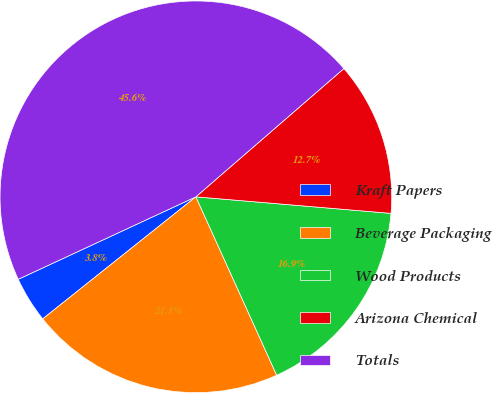Convert chart to OTSL. <chart><loc_0><loc_0><loc_500><loc_500><pie_chart><fcel>Kraft Papers<fcel>Beverage Packaging<fcel>Wood Products<fcel>Arizona Chemical<fcel>Totals<nl><fcel>3.79%<fcel>21.06%<fcel>16.88%<fcel>12.71%<fcel>45.55%<nl></chart> 